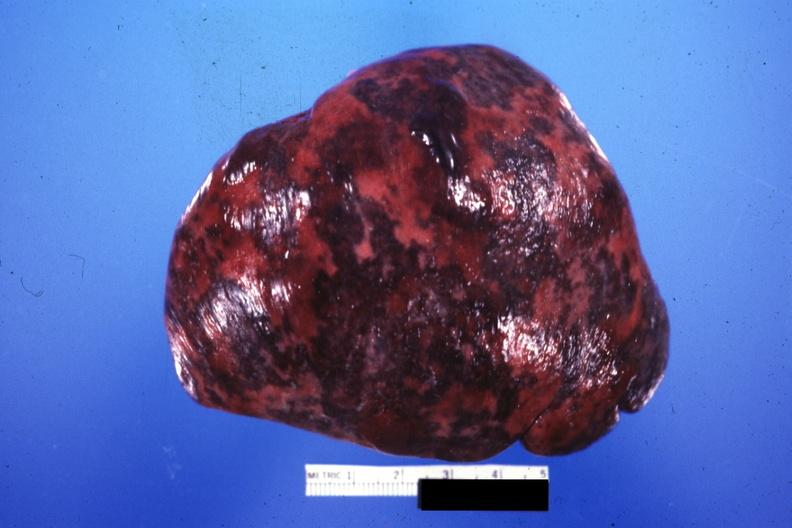s omphalocele present?
Answer the question using a single word or phrase. No 